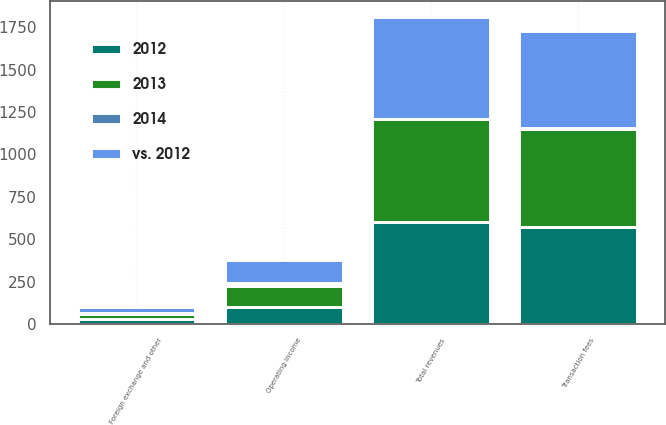<chart> <loc_0><loc_0><loc_500><loc_500><stacked_bar_chart><ecel><fcel>Transaction fees<fcel>Foreign exchange and other<fcel>Total revenues<fcel>Operating income<nl><fcel>2012<fcel>572.7<fcel>26.1<fcel>598.8<fcel>98.7<nl><fcel>2013<fcel>579.1<fcel>29.4<fcel>608.5<fcel>121.9<nl><fcel>vs. 2012<fcel>573.6<fcel>30.3<fcel>603.9<fcel>137.6<nl><fcel>2014<fcel>1<fcel>11<fcel>2<fcel>19<nl></chart> 